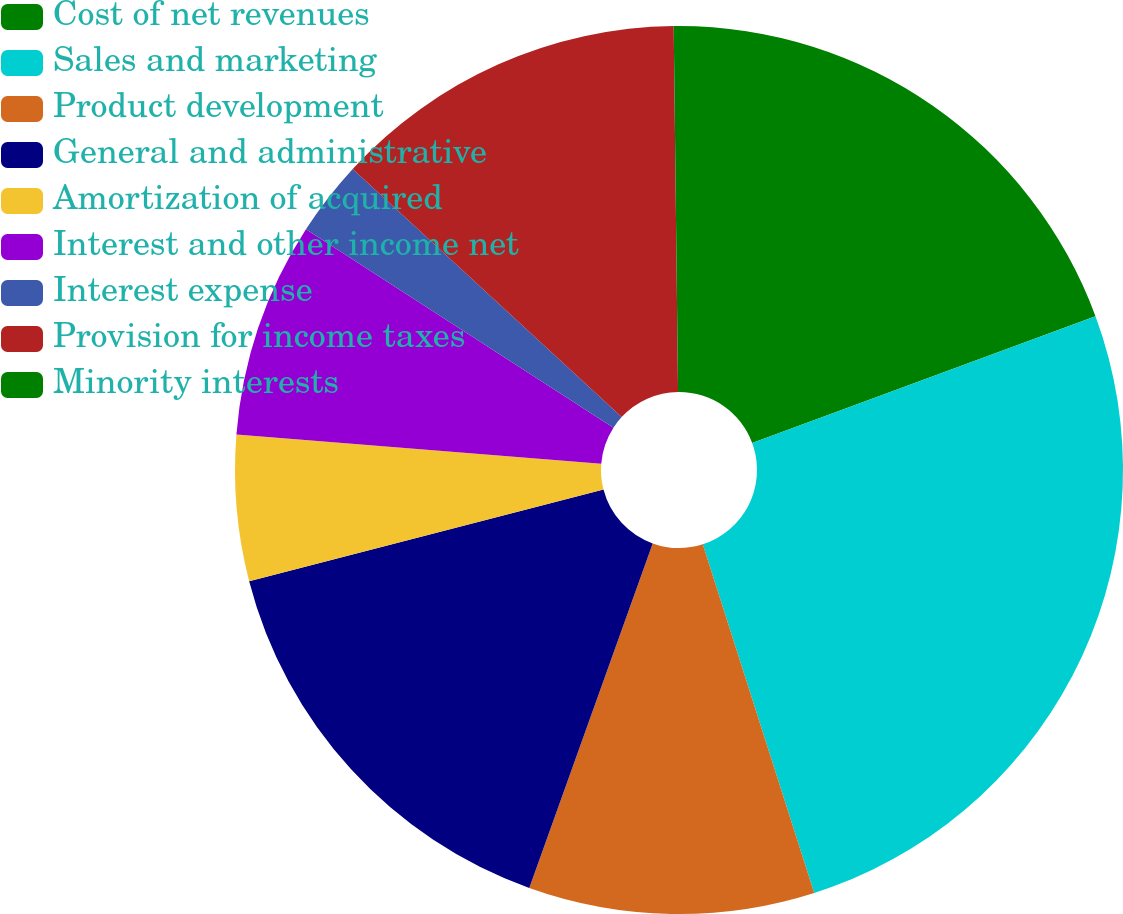Convert chart to OTSL. <chart><loc_0><loc_0><loc_500><loc_500><pie_chart><fcel>Cost of net revenues<fcel>Sales and marketing<fcel>Product development<fcel>General and administrative<fcel>Amortization of acquired<fcel>Interest and other income net<fcel>Interest expense<fcel>Provision for income taxes<fcel>Minority interests<nl><fcel>19.37%<fcel>25.71%<fcel>10.4%<fcel>15.5%<fcel>5.3%<fcel>7.85%<fcel>2.74%<fcel>12.95%<fcel>0.19%<nl></chart> 